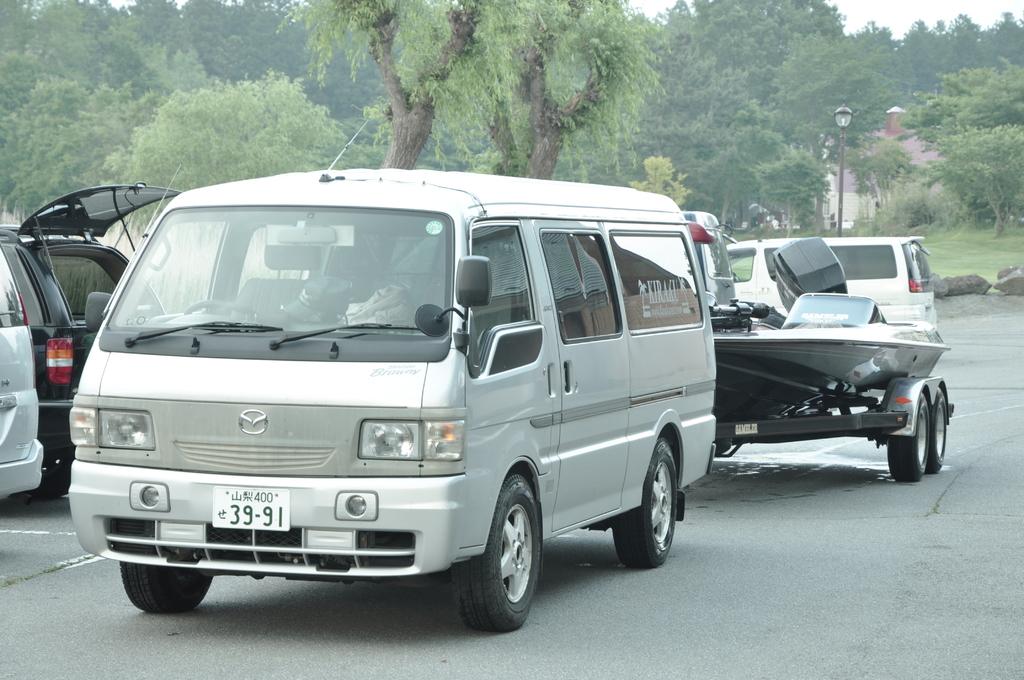What numbers identify the van?
Your response must be concise. 39 91. 